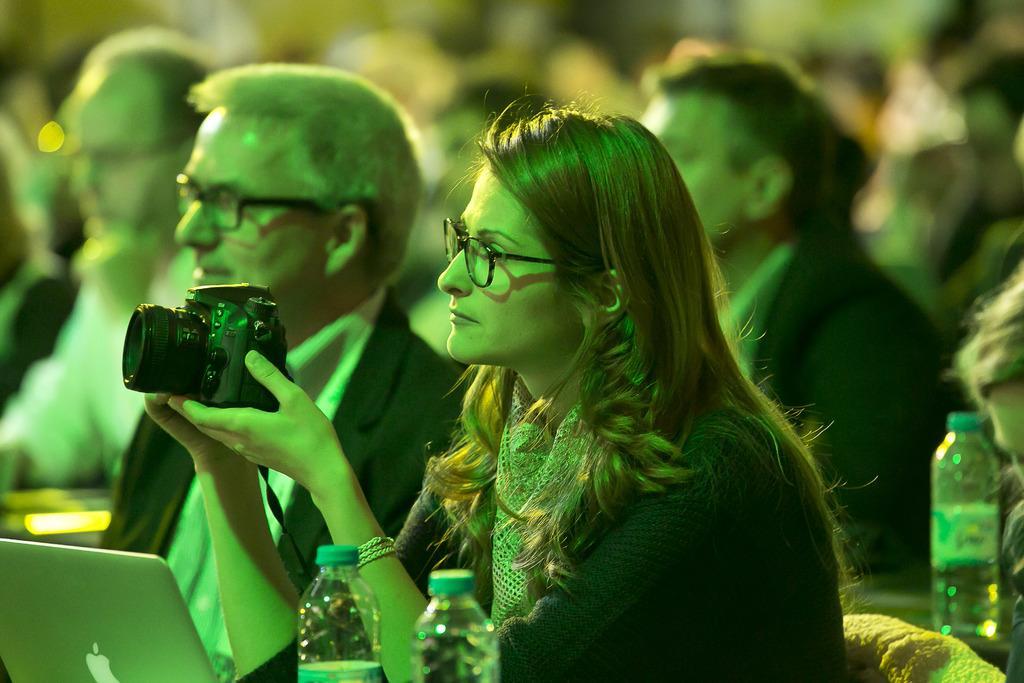Please provide a concise description of this image. This picture shows few people seated and we see a man holding a camera in hand and we see few water bottles and a laptop 